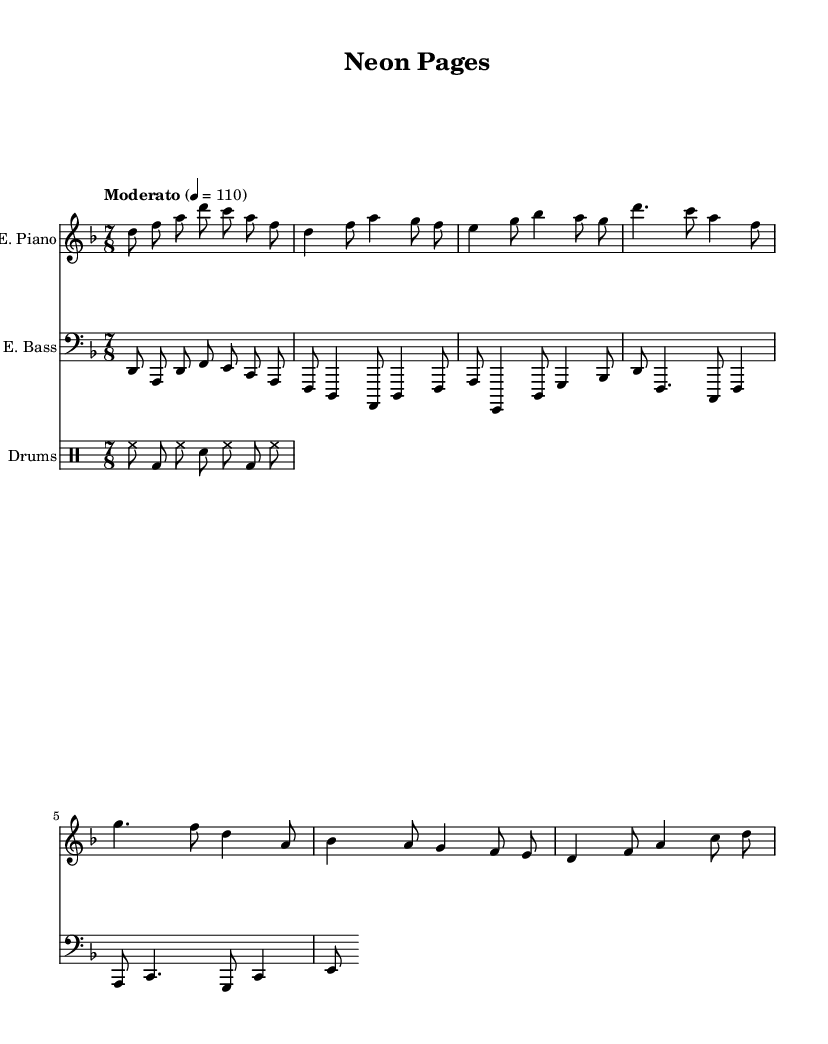What is the key signature of this music? The key signature indicated is D minor, which includes one flat (B flat). This is noted at the beginning of the score where the key signature is shown.
Answer: D minor What is the time signature of the piece? The time signature shown is 7/8, meaning there are seven eighth notes in each measure. This is also displayed at the beginning of the score next to the key signature.
Answer: 7/8 What is the tempo marking for this sheet music? The tempo marking reads "Moderato" with a metronome marking of quarter note = 110. This indicates a moderate pace at which the piece should be played.
Answer: Moderato How many measures are in the Verse section? By counting the measures in the Verse part, which consists of two lines, we find a total of four measures.
Answer: 4 What instruments are featured in this score? The score features an electric piano, an electric bass, and drums, all specified at the beginning of their respective staff sections.
Answer: Electric piano, electric bass, drums What is the rhythmic pattern of the drum section? The drum pattern specifically uses a combination of hi-hat, bass drum, and snare, laid out in the drummode. The pattern alternates between these elements in a simple 7/8 rhythm.
Answer: Hi-hat, bass drum, snare What is the structure of the piece? The overall structure can be identified as Intro, Verse, Chorus, and Bridge. Each section has distinct musical ideas introduced, which is typical of jazz-rock fusion compositions.
Answer: Intro, Verse, Chorus, Bridge 